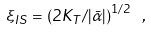Convert formula to latex. <formula><loc_0><loc_0><loc_500><loc_500>\xi _ { I S } = \left ( 2 K _ { T } / | { \bar { \alpha } } | \right ) ^ { 1 / 2 } \ ,</formula> 